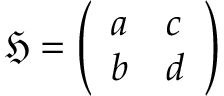Convert formula to latex. <formula><loc_0><loc_0><loc_500><loc_500>{ \mathfrak { H } } = { \left ( \begin{array} { l l } { a } & { c } \\ { b } & { d } \end{array} \right ) }</formula> 